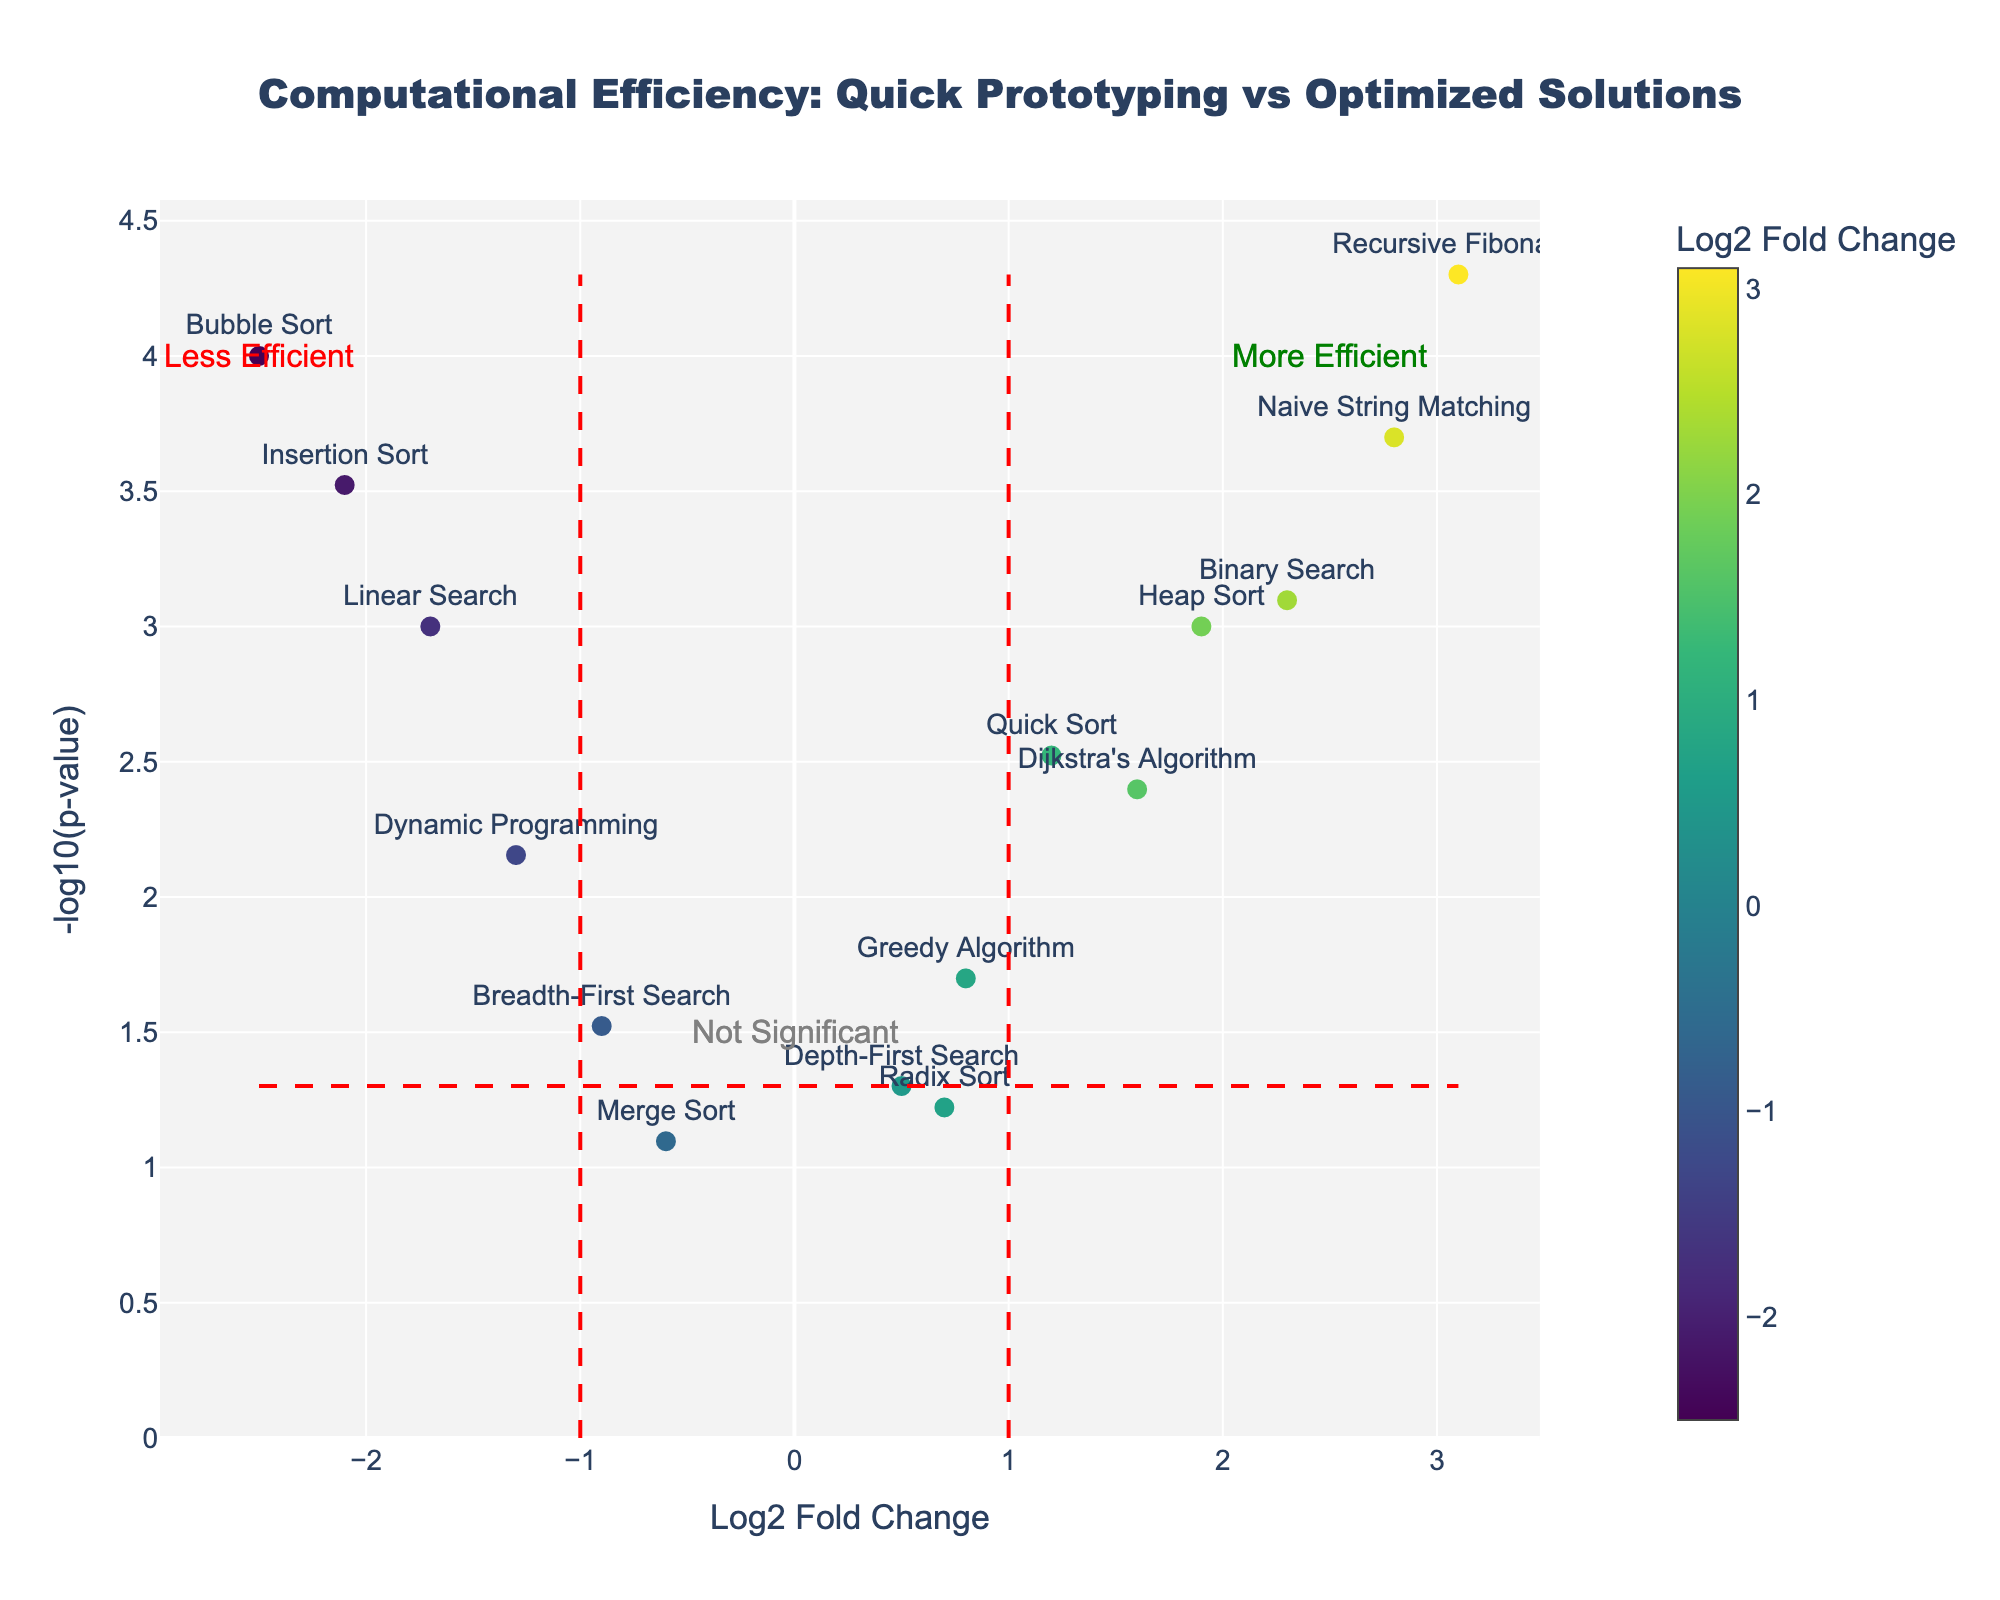What is the title of the figure? The title of the figure is typically displayed prominently at the top of the plot. Looking at the figure, the title is: "Computational Efficiency: Quick Prototyping vs Optimized Solutions".
Answer: Computational Efficiency: Quick Prototyping vs Optimized Solutions What is the y-axis representing in the plot? The y-axis represents the negative log of the p-value, noted as "-log10(p-value)". This transformation emphasizes the significance, with higher values indicating more significant results.
Answer: -log10(p-value) How many algorithms have a Log2 Fold Change greater than 1.5? To find the number of algorithms with a Log2 Fold Change greater than 1.5, locate the data points to the right of x=1.5. From the figure, the algorithms are Recursive Fibonacci, Binary Search, Naive String Matching, Dijkstra's Algorithm, and Heap Sort.
Answer: 5 Which algorithm is the least efficient according to the plot? The least efficient algorithm will have the most negative Log2 Fold Change. From the plot, Bubble Sort has the lowest Log2 Fold Change at -2.5.
Answer: Bubble Sort Which algorithm has the smallest p-value, thus the highest significance? The smallest p-value will correspond to the highest point on the y-axis. From the plot, Recursive Fibonacci has the highest -log10(p-value), indicating the smallest p-value.
Answer: Recursive Fibonacci What does the vertical dotted line at x=1 signify? The vertical line at x=1 serves as a threshold to differentiate between significant positive Log2 Fold Change (indicative of higher computational efficiency) and less efficient or insignificant changes. Algorithms to the right of this line are considered more efficient.
Answer: Threshold for significant positive change Which algorithms fall within the "More Efficient" region? The "More Efficient" region is to the right of the vertical line at x=1 and above the horizontal line at -log10(p-value) = 1.3. These include Recursive Fibonacci, Binary Search, Naive String Matching, Dijkstra's Algorithm, and Heap Sort.
Answer: Recursive Fibonacci, Binary Search, Naive String Matching, Dijkstra's Algorithm, Heap Sort Identify an algorithm in the "Not Significant" area and provide its p-value. "Not Significant" algorithms are below the horizontal line at -log10(p-value) = 1.3. Merge Sort is an example falling in this area, with a p-value of 0.08.
Answer: Merge Sort, 0.08 What does the horizontal dotted line at y=-log10(0.05) represent? The horizontal line at y=-log10(0.05) serves as a threshold for statistical significance. Data points above this line have p-values less than 0.05, indicating significant results.
Answer: Threshold for statistical significance 